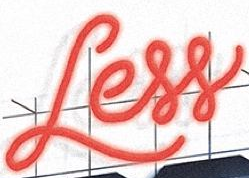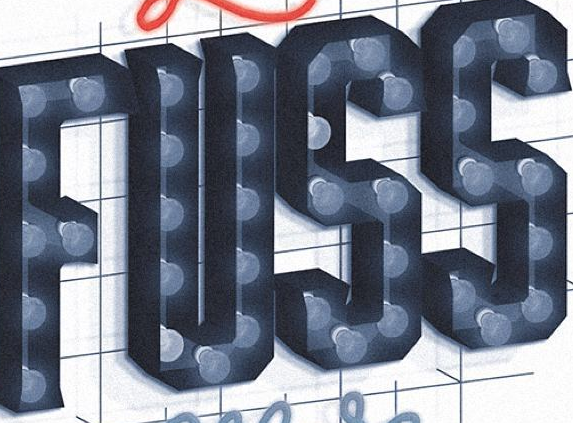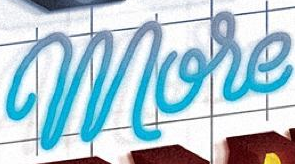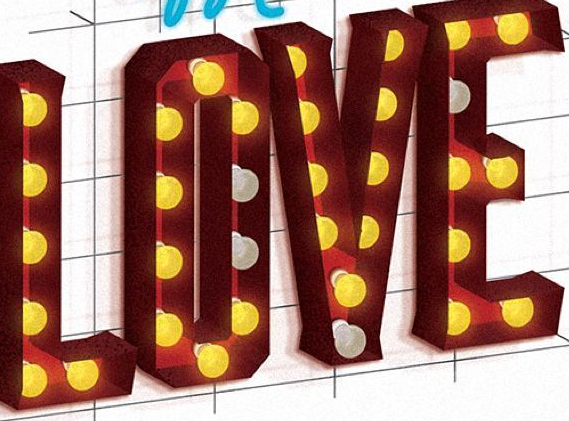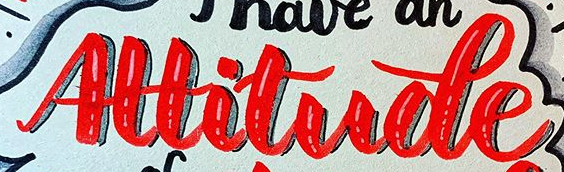Read the text content from these images in order, separated by a semicolon. Less; FUSS; More; LOVE; Altitude 